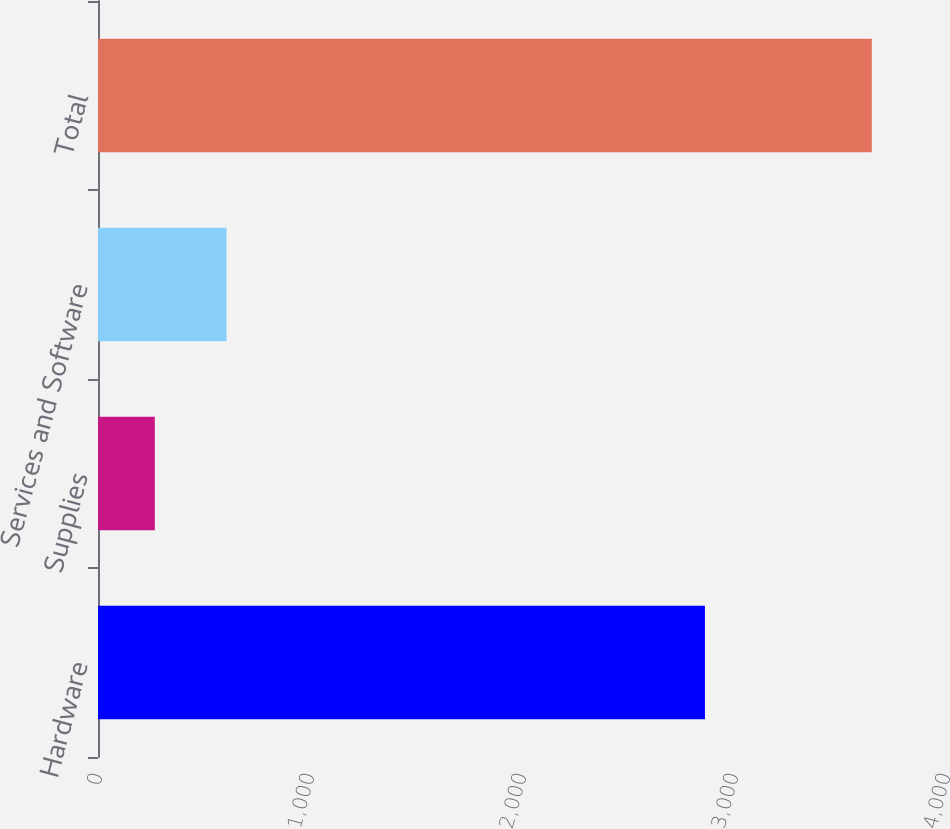Convert chart to OTSL. <chart><loc_0><loc_0><loc_500><loc_500><bar_chart><fcel>Hardware<fcel>Supplies<fcel>Services and Software<fcel>Total<nl><fcel>2863<fcel>268<fcel>606.2<fcel>3650<nl></chart> 